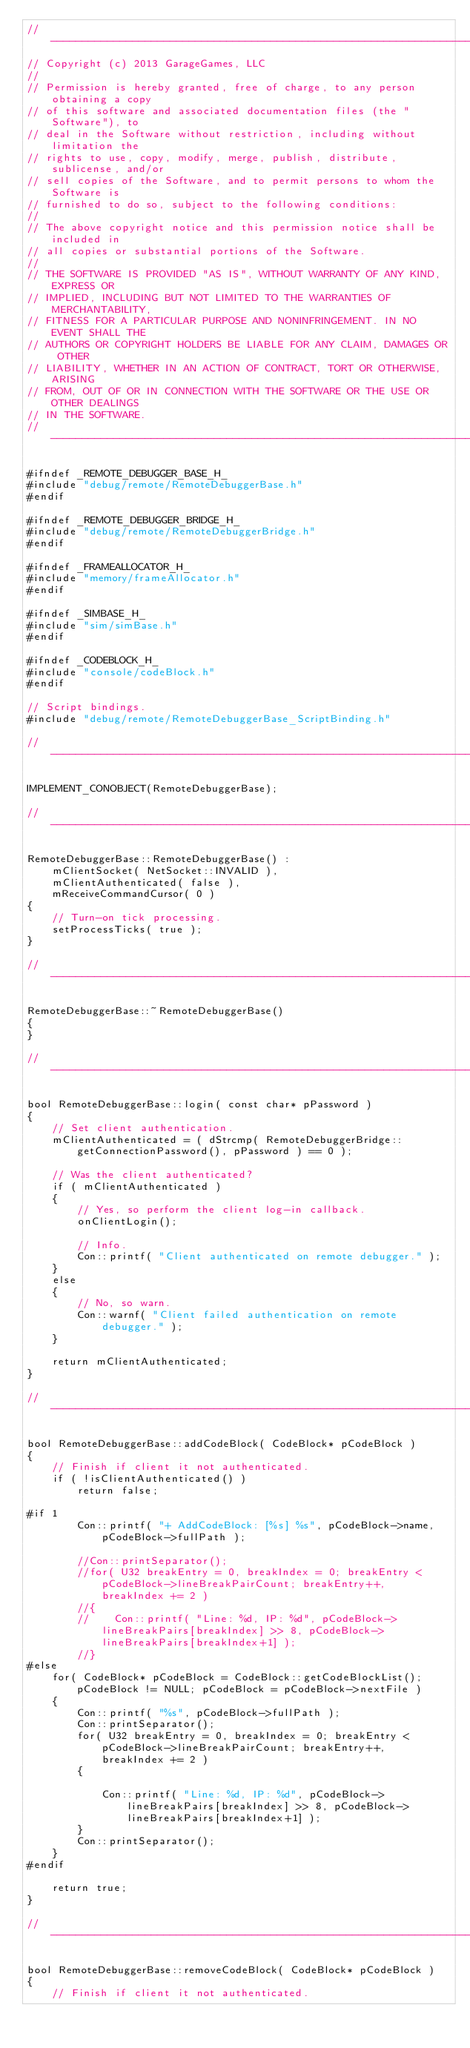<code> <loc_0><loc_0><loc_500><loc_500><_C++_>//-----------------------------------------------------------------------------
// Copyright (c) 2013 GarageGames, LLC
//
// Permission is hereby granted, free of charge, to any person obtaining a copy
// of this software and associated documentation files (the "Software"), to
// deal in the Software without restriction, including without limitation the
// rights to use, copy, modify, merge, publish, distribute, sublicense, and/or
// sell copies of the Software, and to permit persons to whom the Software is
// furnished to do so, subject to the following conditions:
//
// The above copyright notice and this permission notice shall be included in
// all copies or substantial portions of the Software.
//
// THE SOFTWARE IS PROVIDED "AS IS", WITHOUT WARRANTY OF ANY KIND, EXPRESS OR
// IMPLIED, INCLUDING BUT NOT LIMITED TO THE WARRANTIES OF MERCHANTABILITY,
// FITNESS FOR A PARTICULAR PURPOSE AND NONINFRINGEMENT. IN NO EVENT SHALL THE
// AUTHORS OR COPYRIGHT HOLDERS BE LIABLE FOR ANY CLAIM, DAMAGES OR OTHER
// LIABILITY, WHETHER IN AN ACTION OF CONTRACT, TORT OR OTHERWISE, ARISING
// FROM, OUT OF OR IN CONNECTION WITH THE SOFTWARE OR THE USE OR OTHER DEALINGS
// IN THE SOFTWARE.
//-----------------------------------------------------------------------------

#ifndef _REMOTE_DEBUGGER_BASE_H_
#include "debug/remote/RemoteDebuggerBase.h"
#endif

#ifndef _REMOTE_DEBUGGER_BRIDGE_H_
#include "debug/remote/RemoteDebuggerBridge.h"
#endif

#ifndef _FRAMEALLOCATOR_H_
#include "memory/frameAllocator.h"
#endif

#ifndef _SIMBASE_H_
#include "sim/simBase.h"
#endif

#ifndef _CODEBLOCK_H_
#include "console/codeBlock.h"
#endif

// Script bindings.
#include "debug/remote/RemoteDebuggerBase_ScriptBinding.h"

//-----------------------------------------------------------------------------

IMPLEMENT_CONOBJECT(RemoteDebuggerBase);

//-----------------------------------------------------------------------------

RemoteDebuggerBase::RemoteDebuggerBase() :
    mClientSocket( NetSocket::INVALID ),
    mClientAuthenticated( false ),
    mReceiveCommandCursor( 0 )
{
    // Turn-on tick processing.
    setProcessTicks( true );
}

//-----------------------------------------------------------------------------

RemoteDebuggerBase::~RemoteDebuggerBase()
{
}

//-----------------------------------------------------------------------------

bool RemoteDebuggerBase::login( const char* pPassword )
{
    // Set client authentication.
    mClientAuthenticated = ( dStrcmp( RemoteDebuggerBridge::getConnectionPassword(), pPassword ) == 0 );

    // Was the client authenticated?
    if ( mClientAuthenticated )
    {
        // Yes, so perform the client log-in callback.
        onClientLogin();

        // Info.
        Con::printf( "Client authenticated on remote debugger." );
    }
    else
    {
        // No, so warn.
        Con::warnf( "Client failed authentication on remote debugger." );
    }

    return mClientAuthenticated;
}

//-----------------------------------------------------------------------------

bool RemoteDebuggerBase::addCodeBlock( CodeBlock* pCodeBlock )
{
    // Finish if client it not authenticated.
    if ( !isClientAuthenticated() )
        return false;

#if 1
        Con::printf( "+ AddCodeBlock: [%s] %s", pCodeBlock->name, pCodeBlock->fullPath );

        //Con::printSeparator();
        //for( U32 breakEntry = 0, breakIndex = 0; breakEntry < pCodeBlock->lineBreakPairCount; breakEntry++, breakIndex += 2 )
        //{
        //    Con::printf( "Line: %d, IP: %d", pCodeBlock->lineBreakPairs[breakIndex] >> 8, pCodeBlock->lineBreakPairs[breakIndex+1] );
        //}
#else
    for( CodeBlock* pCodeBlock = CodeBlock::getCodeBlockList(); pCodeBlock != NULL; pCodeBlock = pCodeBlock->nextFile )
    {
        Con::printf( "%s", pCodeBlock->fullPath );
        Con::printSeparator();
        for( U32 breakEntry = 0, breakIndex = 0; breakEntry < pCodeBlock->lineBreakPairCount; breakEntry++, breakIndex += 2 )
        {

            Con::printf( "Line: %d, IP: %d", pCodeBlock->lineBreakPairs[breakIndex] >> 8, pCodeBlock->lineBreakPairs[breakIndex+1] );
        }
        Con::printSeparator();
    }
#endif

    return true;
}

//-----------------------------------------------------------------------------

bool RemoteDebuggerBase::removeCodeBlock( CodeBlock* pCodeBlock )
{
    // Finish if client it not authenticated.</code> 